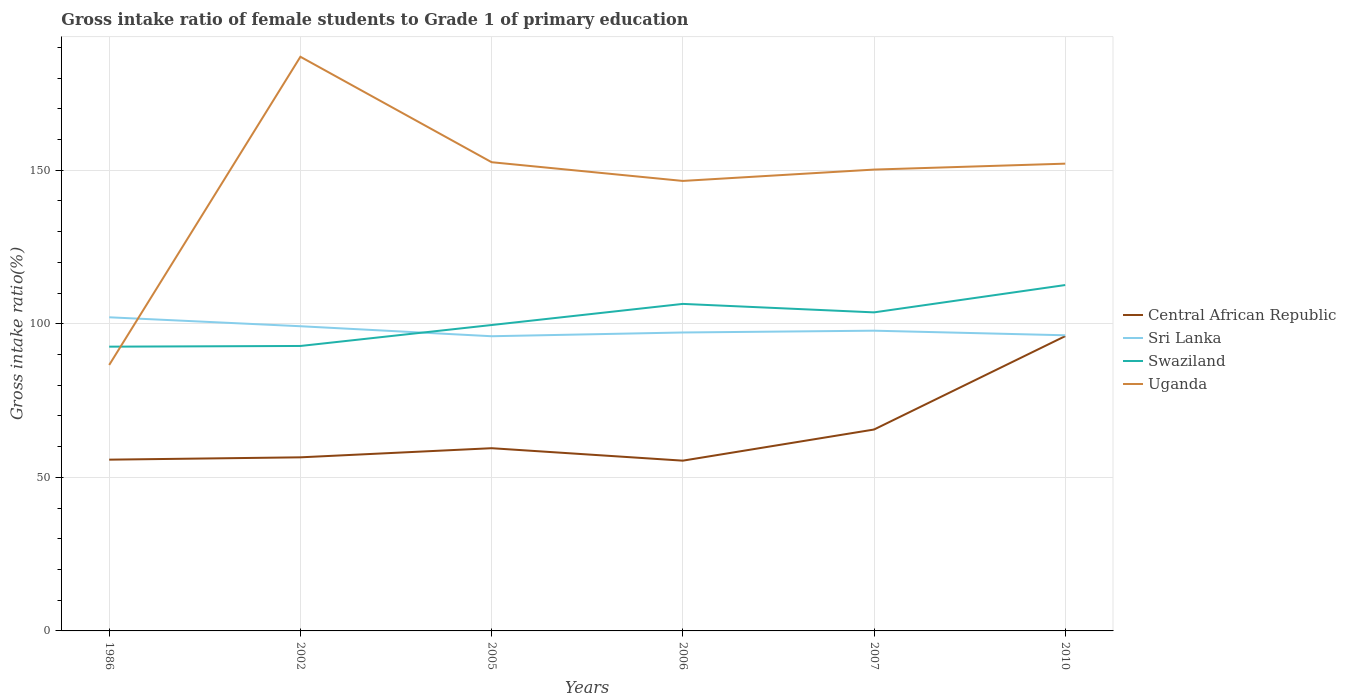Does the line corresponding to Swaziland intersect with the line corresponding to Central African Republic?
Your answer should be compact. No. Is the number of lines equal to the number of legend labels?
Keep it short and to the point. Yes. Across all years, what is the maximum gross intake ratio in Central African Republic?
Provide a succinct answer. 55.44. In which year was the gross intake ratio in Uganda maximum?
Offer a very short reply. 1986. What is the total gross intake ratio in Sri Lanka in the graph?
Offer a terse response. 1.49. What is the difference between the highest and the second highest gross intake ratio in Sri Lanka?
Offer a very short reply. 6.17. Is the gross intake ratio in Swaziland strictly greater than the gross intake ratio in Uganda over the years?
Provide a short and direct response. No. How many years are there in the graph?
Give a very brief answer. 6. Are the values on the major ticks of Y-axis written in scientific E-notation?
Make the answer very short. No. Does the graph contain grids?
Your response must be concise. Yes. What is the title of the graph?
Provide a succinct answer. Gross intake ratio of female students to Grade 1 of primary education. Does "Cameroon" appear as one of the legend labels in the graph?
Offer a terse response. No. What is the label or title of the Y-axis?
Offer a very short reply. Gross intake ratio(%). What is the Gross intake ratio(%) in Central African Republic in 1986?
Offer a terse response. 55.77. What is the Gross intake ratio(%) in Sri Lanka in 1986?
Keep it short and to the point. 102.13. What is the Gross intake ratio(%) of Swaziland in 1986?
Offer a terse response. 92.57. What is the Gross intake ratio(%) in Uganda in 1986?
Make the answer very short. 86.6. What is the Gross intake ratio(%) in Central African Republic in 2002?
Your answer should be compact. 56.53. What is the Gross intake ratio(%) of Sri Lanka in 2002?
Offer a terse response. 99.21. What is the Gross intake ratio(%) of Swaziland in 2002?
Ensure brevity in your answer.  92.79. What is the Gross intake ratio(%) in Uganda in 2002?
Your answer should be compact. 186.96. What is the Gross intake ratio(%) in Central African Republic in 2005?
Keep it short and to the point. 59.5. What is the Gross intake ratio(%) of Sri Lanka in 2005?
Keep it short and to the point. 95.96. What is the Gross intake ratio(%) in Swaziland in 2005?
Give a very brief answer. 99.61. What is the Gross intake ratio(%) of Uganda in 2005?
Make the answer very short. 152.63. What is the Gross intake ratio(%) in Central African Republic in 2006?
Your answer should be very brief. 55.44. What is the Gross intake ratio(%) in Sri Lanka in 2006?
Your answer should be very brief. 97.18. What is the Gross intake ratio(%) in Swaziland in 2006?
Ensure brevity in your answer.  106.49. What is the Gross intake ratio(%) in Uganda in 2006?
Provide a succinct answer. 146.53. What is the Gross intake ratio(%) of Central African Republic in 2007?
Your answer should be compact. 65.58. What is the Gross intake ratio(%) of Sri Lanka in 2007?
Make the answer very short. 97.76. What is the Gross intake ratio(%) of Swaziland in 2007?
Your response must be concise. 103.73. What is the Gross intake ratio(%) in Uganda in 2007?
Give a very brief answer. 150.23. What is the Gross intake ratio(%) of Central African Republic in 2010?
Your response must be concise. 95.99. What is the Gross intake ratio(%) of Sri Lanka in 2010?
Your response must be concise. 96.27. What is the Gross intake ratio(%) in Swaziland in 2010?
Ensure brevity in your answer.  112.63. What is the Gross intake ratio(%) in Uganda in 2010?
Provide a short and direct response. 152.16. Across all years, what is the maximum Gross intake ratio(%) of Central African Republic?
Offer a terse response. 95.99. Across all years, what is the maximum Gross intake ratio(%) of Sri Lanka?
Offer a terse response. 102.13. Across all years, what is the maximum Gross intake ratio(%) in Swaziland?
Offer a very short reply. 112.63. Across all years, what is the maximum Gross intake ratio(%) of Uganda?
Make the answer very short. 186.96. Across all years, what is the minimum Gross intake ratio(%) in Central African Republic?
Your answer should be very brief. 55.44. Across all years, what is the minimum Gross intake ratio(%) in Sri Lanka?
Your answer should be very brief. 95.96. Across all years, what is the minimum Gross intake ratio(%) in Swaziland?
Offer a very short reply. 92.57. Across all years, what is the minimum Gross intake ratio(%) of Uganda?
Keep it short and to the point. 86.6. What is the total Gross intake ratio(%) of Central African Republic in the graph?
Give a very brief answer. 388.81. What is the total Gross intake ratio(%) of Sri Lanka in the graph?
Your response must be concise. 588.52. What is the total Gross intake ratio(%) of Swaziland in the graph?
Keep it short and to the point. 607.82. What is the total Gross intake ratio(%) of Uganda in the graph?
Offer a very short reply. 875.12. What is the difference between the Gross intake ratio(%) in Central African Republic in 1986 and that in 2002?
Offer a terse response. -0.76. What is the difference between the Gross intake ratio(%) of Sri Lanka in 1986 and that in 2002?
Your answer should be very brief. 2.91. What is the difference between the Gross intake ratio(%) of Swaziland in 1986 and that in 2002?
Your response must be concise. -0.22. What is the difference between the Gross intake ratio(%) in Uganda in 1986 and that in 2002?
Give a very brief answer. -100.36. What is the difference between the Gross intake ratio(%) in Central African Republic in 1986 and that in 2005?
Ensure brevity in your answer.  -3.73. What is the difference between the Gross intake ratio(%) of Sri Lanka in 1986 and that in 2005?
Ensure brevity in your answer.  6.17. What is the difference between the Gross intake ratio(%) in Swaziland in 1986 and that in 2005?
Ensure brevity in your answer.  -7.05. What is the difference between the Gross intake ratio(%) of Uganda in 1986 and that in 2005?
Provide a short and direct response. -66.03. What is the difference between the Gross intake ratio(%) in Central African Republic in 1986 and that in 2006?
Your answer should be very brief. 0.33. What is the difference between the Gross intake ratio(%) in Sri Lanka in 1986 and that in 2006?
Keep it short and to the point. 4.95. What is the difference between the Gross intake ratio(%) of Swaziland in 1986 and that in 2006?
Keep it short and to the point. -13.92. What is the difference between the Gross intake ratio(%) in Uganda in 1986 and that in 2006?
Offer a very short reply. -59.93. What is the difference between the Gross intake ratio(%) in Central African Republic in 1986 and that in 2007?
Ensure brevity in your answer.  -9.81. What is the difference between the Gross intake ratio(%) of Sri Lanka in 1986 and that in 2007?
Give a very brief answer. 4.37. What is the difference between the Gross intake ratio(%) in Swaziland in 1986 and that in 2007?
Keep it short and to the point. -11.16. What is the difference between the Gross intake ratio(%) of Uganda in 1986 and that in 2007?
Your answer should be compact. -63.63. What is the difference between the Gross intake ratio(%) of Central African Republic in 1986 and that in 2010?
Keep it short and to the point. -40.23. What is the difference between the Gross intake ratio(%) in Sri Lanka in 1986 and that in 2010?
Your answer should be very brief. 5.86. What is the difference between the Gross intake ratio(%) of Swaziland in 1986 and that in 2010?
Your answer should be compact. -20.07. What is the difference between the Gross intake ratio(%) of Uganda in 1986 and that in 2010?
Your answer should be compact. -65.56. What is the difference between the Gross intake ratio(%) in Central African Republic in 2002 and that in 2005?
Make the answer very short. -2.97. What is the difference between the Gross intake ratio(%) of Sri Lanka in 2002 and that in 2005?
Provide a succinct answer. 3.25. What is the difference between the Gross intake ratio(%) in Swaziland in 2002 and that in 2005?
Offer a very short reply. -6.82. What is the difference between the Gross intake ratio(%) in Uganda in 2002 and that in 2005?
Offer a terse response. 34.33. What is the difference between the Gross intake ratio(%) of Central African Republic in 2002 and that in 2006?
Offer a very short reply. 1.08. What is the difference between the Gross intake ratio(%) of Sri Lanka in 2002 and that in 2006?
Offer a terse response. 2.03. What is the difference between the Gross intake ratio(%) of Swaziland in 2002 and that in 2006?
Keep it short and to the point. -13.7. What is the difference between the Gross intake ratio(%) of Uganda in 2002 and that in 2006?
Make the answer very short. 40.43. What is the difference between the Gross intake ratio(%) of Central African Republic in 2002 and that in 2007?
Your response must be concise. -9.05. What is the difference between the Gross intake ratio(%) in Sri Lanka in 2002 and that in 2007?
Provide a succinct answer. 1.45. What is the difference between the Gross intake ratio(%) in Swaziland in 2002 and that in 2007?
Provide a short and direct response. -10.94. What is the difference between the Gross intake ratio(%) of Uganda in 2002 and that in 2007?
Provide a short and direct response. 36.73. What is the difference between the Gross intake ratio(%) in Central African Republic in 2002 and that in 2010?
Offer a terse response. -39.47. What is the difference between the Gross intake ratio(%) in Sri Lanka in 2002 and that in 2010?
Give a very brief answer. 2.95. What is the difference between the Gross intake ratio(%) of Swaziland in 2002 and that in 2010?
Provide a short and direct response. -19.84. What is the difference between the Gross intake ratio(%) in Uganda in 2002 and that in 2010?
Offer a very short reply. 34.8. What is the difference between the Gross intake ratio(%) of Central African Republic in 2005 and that in 2006?
Offer a very short reply. 4.06. What is the difference between the Gross intake ratio(%) in Sri Lanka in 2005 and that in 2006?
Make the answer very short. -1.22. What is the difference between the Gross intake ratio(%) of Swaziland in 2005 and that in 2006?
Keep it short and to the point. -6.88. What is the difference between the Gross intake ratio(%) of Uganda in 2005 and that in 2006?
Keep it short and to the point. 6.09. What is the difference between the Gross intake ratio(%) in Central African Republic in 2005 and that in 2007?
Your answer should be very brief. -6.08. What is the difference between the Gross intake ratio(%) of Sri Lanka in 2005 and that in 2007?
Ensure brevity in your answer.  -1.8. What is the difference between the Gross intake ratio(%) of Swaziland in 2005 and that in 2007?
Give a very brief answer. -4.12. What is the difference between the Gross intake ratio(%) of Uganda in 2005 and that in 2007?
Provide a succinct answer. 2.4. What is the difference between the Gross intake ratio(%) of Central African Republic in 2005 and that in 2010?
Provide a succinct answer. -36.49. What is the difference between the Gross intake ratio(%) in Sri Lanka in 2005 and that in 2010?
Provide a succinct answer. -0.31. What is the difference between the Gross intake ratio(%) of Swaziland in 2005 and that in 2010?
Your answer should be very brief. -13.02. What is the difference between the Gross intake ratio(%) in Uganda in 2005 and that in 2010?
Ensure brevity in your answer.  0.47. What is the difference between the Gross intake ratio(%) of Central African Republic in 2006 and that in 2007?
Ensure brevity in your answer.  -10.14. What is the difference between the Gross intake ratio(%) in Sri Lanka in 2006 and that in 2007?
Give a very brief answer. -0.58. What is the difference between the Gross intake ratio(%) in Swaziland in 2006 and that in 2007?
Provide a short and direct response. 2.76. What is the difference between the Gross intake ratio(%) of Uganda in 2006 and that in 2007?
Provide a succinct answer. -3.69. What is the difference between the Gross intake ratio(%) of Central African Republic in 2006 and that in 2010?
Provide a short and direct response. -40.55. What is the difference between the Gross intake ratio(%) in Sri Lanka in 2006 and that in 2010?
Ensure brevity in your answer.  0.91. What is the difference between the Gross intake ratio(%) in Swaziland in 2006 and that in 2010?
Ensure brevity in your answer.  -6.14. What is the difference between the Gross intake ratio(%) in Uganda in 2006 and that in 2010?
Your response must be concise. -5.63. What is the difference between the Gross intake ratio(%) of Central African Republic in 2007 and that in 2010?
Give a very brief answer. -30.41. What is the difference between the Gross intake ratio(%) in Sri Lanka in 2007 and that in 2010?
Your answer should be compact. 1.49. What is the difference between the Gross intake ratio(%) of Swaziland in 2007 and that in 2010?
Your answer should be compact. -8.9. What is the difference between the Gross intake ratio(%) in Uganda in 2007 and that in 2010?
Make the answer very short. -1.93. What is the difference between the Gross intake ratio(%) in Central African Republic in 1986 and the Gross intake ratio(%) in Sri Lanka in 2002?
Give a very brief answer. -43.45. What is the difference between the Gross intake ratio(%) of Central African Republic in 1986 and the Gross intake ratio(%) of Swaziland in 2002?
Provide a succinct answer. -37.02. What is the difference between the Gross intake ratio(%) of Central African Republic in 1986 and the Gross intake ratio(%) of Uganda in 2002?
Make the answer very short. -131.19. What is the difference between the Gross intake ratio(%) of Sri Lanka in 1986 and the Gross intake ratio(%) of Swaziland in 2002?
Provide a short and direct response. 9.34. What is the difference between the Gross intake ratio(%) in Sri Lanka in 1986 and the Gross intake ratio(%) in Uganda in 2002?
Your answer should be compact. -84.83. What is the difference between the Gross intake ratio(%) in Swaziland in 1986 and the Gross intake ratio(%) in Uganda in 2002?
Give a very brief answer. -94.4. What is the difference between the Gross intake ratio(%) of Central African Republic in 1986 and the Gross intake ratio(%) of Sri Lanka in 2005?
Ensure brevity in your answer.  -40.19. What is the difference between the Gross intake ratio(%) in Central African Republic in 1986 and the Gross intake ratio(%) in Swaziland in 2005?
Keep it short and to the point. -43.84. What is the difference between the Gross intake ratio(%) in Central African Republic in 1986 and the Gross intake ratio(%) in Uganda in 2005?
Offer a very short reply. -96.86. What is the difference between the Gross intake ratio(%) of Sri Lanka in 1986 and the Gross intake ratio(%) of Swaziland in 2005?
Your answer should be very brief. 2.52. What is the difference between the Gross intake ratio(%) in Sri Lanka in 1986 and the Gross intake ratio(%) in Uganda in 2005?
Ensure brevity in your answer.  -50.5. What is the difference between the Gross intake ratio(%) in Swaziland in 1986 and the Gross intake ratio(%) in Uganda in 2005?
Your response must be concise. -60.06. What is the difference between the Gross intake ratio(%) of Central African Republic in 1986 and the Gross intake ratio(%) of Sri Lanka in 2006?
Make the answer very short. -41.41. What is the difference between the Gross intake ratio(%) in Central African Republic in 1986 and the Gross intake ratio(%) in Swaziland in 2006?
Your answer should be very brief. -50.72. What is the difference between the Gross intake ratio(%) in Central African Republic in 1986 and the Gross intake ratio(%) in Uganda in 2006?
Provide a succinct answer. -90.76. What is the difference between the Gross intake ratio(%) in Sri Lanka in 1986 and the Gross intake ratio(%) in Swaziland in 2006?
Give a very brief answer. -4.36. What is the difference between the Gross intake ratio(%) in Sri Lanka in 1986 and the Gross intake ratio(%) in Uganda in 2006?
Provide a short and direct response. -44.4. What is the difference between the Gross intake ratio(%) in Swaziland in 1986 and the Gross intake ratio(%) in Uganda in 2006?
Your answer should be very brief. -53.97. What is the difference between the Gross intake ratio(%) of Central African Republic in 1986 and the Gross intake ratio(%) of Sri Lanka in 2007?
Provide a short and direct response. -42. What is the difference between the Gross intake ratio(%) of Central African Republic in 1986 and the Gross intake ratio(%) of Swaziland in 2007?
Keep it short and to the point. -47.96. What is the difference between the Gross intake ratio(%) in Central African Republic in 1986 and the Gross intake ratio(%) in Uganda in 2007?
Provide a short and direct response. -94.46. What is the difference between the Gross intake ratio(%) in Sri Lanka in 1986 and the Gross intake ratio(%) in Swaziland in 2007?
Give a very brief answer. -1.6. What is the difference between the Gross intake ratio(%) in Sri Lanka in 1986 and the Gross intake ratio(%) in Uganda in 2007?
Give a very brief answer. -48.1. What is the difference between the Gross intake ratio(%) in Swaziland in 1986 and the Gross intake ratio(%) in Uganda in 2007?
Your answer should be very brief. -57.66. What is the difference between the Gross intake ratio(%) of Central African Republic in 1986 and the Gross intake ratio(%) of Sri Lanka in 2010?
Keep it short and to the point. -40.5. What is the difference between the Gross intake ratio(%) of Central African Republic in 1986 and the Gross intake ratio(%) of Swaziland in 2010?
Your answer should be very brief. -56.86. What is the difference between the Gross intake ratio(%) in Central African Republic in 1986 and the Gross intake ratio(%) in Uganda in 2010?
Your answer should be very brief. -96.39. What is the difference between the Gross intake ratio(%) of Sri Lanka in 1986 and the Gross intake ratio(%) of Swaziland in 2010?
Your answer should be compact. -10.5. What is the difference between the Gross intake ratio(%) in Sri Lanka in 1986 and the Gross intake ratio(%) in Uganda in 2010?
Give a very brief answer. -50.03. What is the difference between the Gross intake ratio(%) of Swaziland in 1986 and the Gross intake ratio(%) of Uganda in 2010?
Your answer should be compact. -59.59. What is the difference between the Gross intake ratio(%) in Central African Republic in 2002 and the Gross intake ratio(%) in Sri Lanka in 2005?
Provide a succinct answer. -39.43. What is the difference between the Gross intake ratio(%) of Central African Republic in 2002 and the Gross intake ratio(%) of Swaziland in 2005?
Provide a succinct answer. -43.09. What is the difference between the Gross intake ratio(%) of Central African Republic in 2002 and the Gross intake ratio(%) of Uganda in 2005?
Provide a succinct answer. -96.1. What is the difference between the Gross intake ratio(%) of Sri Lanka in 2002 and the Gross intake ratio(%) of Swaziland in 2005?
Provide a succinct answer. -0.4. What is the difference between the Gross intake ratio(%) in Sri Lanka in 2002 and the Gross intake ratio(%) in Uganda in 2005?
Make the answer very short. -53.41. What is the difference between the Gross intake ratio(%) in Swaziland in 2002 and the Gross intake ratio(%) in Uganda in 2005?
Your response must be concise. -59.84. What is the difference between the Gross intake ratio(%) in Central African Republic in 2002 and the Gross intake ratio(%) in Sri Lanka in 2006?
Your response must be concise. -40.66. What is the difference between the Gross intake ratio(%) of Central African Republic in 2002 and the Gross intake ratio(%) of Swaziland in 2006?
Your answer should be compact. -49.96. What is the difference between the Gross intake ratio(%) in Central African Republic in 2002 and the Gross intake ratio(%) in Uganda in 2006?
Your answer should be very brief. -90.01. What is the difference between the Gross intake ratio(%) of Sri Lanka in 2002 and the Gross intake ratio(%) of Swaziland in 2006?
Offer a terse response. -7.27. What is the difference between the Gross intake ratio(%) of Sri Lanka in 2002 and the Gross intake ratio(%) of Uganda in 2006?
Offer a very short reply. -47.32. What is the difference between the Gross intake ratio(%) of Swaziland in 2002 and the Gross intake ratio(%) of Uganda in 2006?
Make the answer very short. -53.75. What is the difference between the Gross intake ratio(%) in Central African Republic in 2002 and the Gross intake ratio(%) in Sri Lanka in 2007?
Your answer should be very brief. -41.24. What is the difference between the Gross intake ratio(%) of Central African Republic in 2002 and the Gross intake ratio(%) of Swaziland in 2007?
Keep it short and to the point. -47.2. What is the difference between the Gross intake ratio(%) of Central African Republic in 2002 and the Gross intake ratio(%) of Uganda in 2007?
Offer a terse response. -93.7. What is the difference between the Gross intake ratio(%) in Sri Lanka in 2002 and the Gross intake ratio(%) in Swaziland in 2007?
Offer a terse response. -4.51. What is the difference between the Gross intake ratio(%) of Sri Lanka in 2002 and the Gross intake ratio(%) of Uganda in 2007?
Provide a succinct answer. -51.01. What is the difference between the Gross intake ratio(%) in Swaziland in 2002 and the Gross intake ratio(%) in Uganda in 2007?
Your answer should be very brief. -57.44. What is the difference between the Gross intake ratio(%) of Central African Republic in 2002 and the Gross intake ratio(%) of Sri Lanka in 2010?
Offer a terse response. -39.74. What is the difference between the Gross intake ratio(%) of Central African Republic in 2002 and the Gross intake ratio(%) of Swaziland in 2010?
Your answer should be very brief. -56.11. What is the difference between the Gross intake ratio(%) in Central African Republic in 2002 and the Gross intake ratio(%) in Uganda in 2010?
Provide a succinct answer. -95.63. What is the difference between the Gross intake ratio(%) of Sri Lanka in 2002 and the Gross intake ratio(%) of Swaziland in 2010?
Ensure brevity in your answer.  -13.42. What is the difference between the Gross intake ratio(%) of Sri Lanka in 2002 and the Gross intake ratio(%) of Uganda in 2010?
Your answer should be compact. -52.94. What is the difference between the Gross intake ratio(%) of Swaziland in 2002 and the Gross intake ratio(%) of Uganda in 2010?
Make the answer very short. -59.37. What is the difference between the Gross intake ratio(%) in Central African Republic in 2005 and the Gross intake ratio(%) in Sri Lanka in 2006?
Offer a very short reply. -37.68. What is the difference between the Gross intake ratio(%) of Central African Republic in 2005 and the Gross intake ratio(%) of Swaziland in 2006?
Offer a very short reply. -46.99. What is the difference between the Gross intake ratio(%) in Central African Republic in 2005 and the Gross intake ratio(%) in Uganda in 2006?
Offer a very short reply. -87.03. What is the difference between the Gross intake ratio(%) of Sri Lanka in 2005 and the Gross intake ratio(%) of Swaziland in 2006?
Provide a short and direct response. -10.53. What is the difference between the Gross intake ratio(%) in Sri Lanka in 2005 and the Gross intake ratio(%) in Uganda in 2006?
Keep it short and to the point. -50.57. What is the difference between the Gross intake ratio(%) in Swaziland in 2005 and the Gross intake ratio(%) in Uganda in 2006?
Offer a terse response. -46.92. What is the difference between the Gross intake ratio(%) of Central African Republic in 2005 and the Gross intake ratio(%) of Sri Lanka in 2007?
Provide a succinct answer. -38.26. What is the difference between the Gross intake ratio(%) of Central African Republic in 2005 and the Gross intake ratio(%) of Swaziland in 2007?
Make the answer very short. -44.23. What is the difference between the Gross intake ratio(%) in Central African Republic in 2005 and the Gross intake ratio(%) in Uganda in 2007?
Offer a very short reply. -90.73. What is the difference between the Gross intake ratio(%) of Sri Lanka in 2005 and the Gross intake ratio(%) of Swaziland in 2007?
Make the answer very short. -7.77. What is the difference between the Gross intake ratio(%) in Sri Lanka in 2005 and the Gross intake ratio(%) in Uganda in 2007?
Provide a succinct answer. -54.27. What is the difference between the Gross intake ratio(%) in Swaziland in 2005 and the Gross intake ratio(%) in Uganda in 2007?
Offer a terse response. -50.62. What is the difference between the Gross intake ratio(%) of Central African Republic in 2005 and the Gross intake ratio(%) of Sri Lanka in 2010?
Give a very brief answer. -36.77. What is the difference between the Gross intake ratio(%) of Central African Republic in 2005 and the Gross intake ratio(%) of Swaziland in 2010?
Ensure brevity in your answer.  -53.13. What is the difference between the Gross intake ratio(%) in Central African Republic in 2005 and the Gross intake ratio(%) in Uganda in 2010?
Offer a terse response. -92.66. What is the difference between the Gross intake ratio(%) in Sri Lanka in 2005 and the Gross intake ratio(%) in Swaziland in 2010?
Offer a terse response. -16.67. What is the difference between the Gross intake ratio(%) of Sri Lanka in 2005 and the Gross intake ratio(%) of Uganda in 2010?
Provide a succinct answer. -56.2. What is the difference between the Gross intake ratio(%) in Swaziland in 2005 and the Gross intake ratio(%) in Uganda in 2010?
Keep it short and to the point. -52.55. What is the difference between the Gross intake ratio(%) of Central African Republic in 2006 and the Gross intake ratio(%) of Sri Lanka in 2007?
Provide a short and direct response. -42.32. What is the difference between the Gross intake ratio(%) in Central African Republic in 2006 and the Gross intake ratio(%) in Swaziland in 2007?
Offer a terse response. -48.29. What is the difference between the Gross intake ratio(%) in Central African Republic in 2006 and the Gross intake ratio(%) in Uganda in 2007?
Provide a short and direct response. -94.79. What is the difference between the Gross intake ratio(%) of Sri Lanka in 2006 and the Gross intake ratio(%) of Swaziland in 2007?
Your response must be concise. -6.55. What is the difference between the Gross intake ratio(%) in Sri Lanka in 2006 and the Gross intake ratio(%) in Uganda in 2007?
Make the answer very short. -53.05. What is the difference between the Gross intake ratio(%) in Swaziland in 2006 and the Gross intake ratio(%) in Uganda in 2007?
Your response must be concise. -43.74. What is the difference between the Gross intake ratio(%) of Central African Republic in 2006 and the Gross intake ratio(%) of Sri Lanka in 2010?
Offer a terse response. -40.83. What is the difference between the Gross intake ratio(%) of Central African Republic in 2006 and the Gross intake ratio(%) of Swaziland in 2010?
Offer a very short reply. -57.19. What is the difference between the Gross intake ratio(%) of Central African Republic in 2006 and the Gross intake ratio(%) of Uganda in 2010?
Your answer should be compact. -96.72. What is the difference between the Gross intake ratio(%) in Sri Lanka in 2006 and the Gross intake ratio(%) in Swaziland in 2010?
Provide a succinct answer. -15.45. What is the difference between the Gross intake ratio(%) in Sri Lanka in 2006 and the Gross intake ratio(%) in Uganda in 2010?
Your answer should be compact. -54.98. What is the difference between the Gross intake ratio(%) of Swaziland in 2006 and the Gross intake ratio(%) of Uganda in 2010?
Offer a very short reply. -45.67. What is the difference between the Gross intake ratio(%) of Central African Republic in 2007 and the Gross intake ratio(%) of Sri Lanka in 2010?
Provide a short and direct response. -30.69. What is the difference between the Gross intake ratio(%) in Central African Republic in 2007 and the Gross intake ratio(%) in Swaziland in 2010?
Ensure brevity in your answer.  -47.05. What is the difference between the Gross intake ratio(%) of Central African Republic in 2007 and the Gross intake ratio(%) of Uganda in 2010?
Make the answer very short. -86.58. What is the difference between the Gross intake ratio(%) in Sri Lanka in 2007 and the Gross intake ratio(%) in Swaziland in 2010?
Your response must be concise. -14.87. What is the difference between the Gross intake ratio(%) in Sri Lanka in 2007 and the Gross intake ratio(%) in Uganda in 2010?
Keep it short and to the point. -54.39. What is the difference between the Gross intake ratio(%) of Swaziland in 2007 and the Gross intake ratio(%) of Uganda in 2010?
Provide a succinct answer. -48.43. What is the average Gross intake ratio(%) in Central African Republic per year?
Ensure brevity in your answer.  64.8. What is the average Gross intake ratio(%) in Sri Lanka per year?
Your answer should be very brief. 98.09. What is the average Gross intake ratio(%) in Swaziland per year?
Offer a very short reply. 101.3. What is the average Gross intake ratio(%) in Uganda per year?
Ensure brevity in your answer.  145.85. In the year 1986, what is the difference between the Gross intake ratio(%) of Central African Republic and Gross intake ratio(%) of Sri Lanka?
Provide a short and direct response. -46.36. In the year 1986, what is the difference between the Gross intake ratio(%) of Central African Republic and Gross intake ratio(%) of Swaziland?
Offer a terse response. -36.8. In the year 1986, what is the difference between the Gross intake ratio(%) of Central African Republic and Gross intake ratio(%) of Uganda?
Ensure brevity in your answer.  -30.83. In the year 1986, what is the difference between the Gross intake ratio(%) of Sri Lanka and Gross intake ratio(%) of Swaziland?
Make the answer very short. 9.56. In the year 1986, what is the difference between the Gross intake ratio(%) of Sri Lanka and Gross intake ratio(%) of Uganda?
Your answer should be very brief. 15.53. In the year 1986, what is the difference between the Gross intake ratio(%) of Swaziland and Gross intake ratio(%) of Uganda?
Offer a terse response. 5.96. In the year 2002, what is the difference between the Gross intake ratio(%) of Central African Republic and Gross intake ratio(%) of Sri Lanka?
Your answer should be compact. -42.69. In the year 2002, what is the difference between the Gross intake ratio(%) of Central African Republic and Gross intake ratio(%) of Swaziland?
Your answer should be compact. -36.26. In the year 2002, what is the difference between the Gross intake ratio(%) of Central African Republic and Gross intake ratio(%) of Uganda?
Offer a terse response. -130.44. In the year 2002, what is the difference between the Gross intake ratio(%) in Sri Lanka and Gross intake ratio(%) in Swaziland?
Ensure brevity in your answer.  6.43. In the year 2002, what is the difference between the Gross intake ratio(%) in Sri Lanka and Gross intake ratio(%) in Uganda?
Offer a terse response. -87.75. In the year 2002, what is the difference between the Gross intake ratio(%) of Swaziland and Gross intake ratio(%) of Uganda?
Give a very brief answer. -94.18. In the year 2005, what is the difference between the Gross intake ratio(%) of Central African Republic and Gross intake ratio(%) of Sri Lanka?
Make the answer very short. -36.46. In the year 2005, what is the difference between the Gross intake ratio(%) of Central African Republic and Gross intake ratio(%) of Swaziland?
Offer a very short reply. -40.11. In the year 2005, what is the difference between the Gross intake ratio(%) of Central African Republic and Gross intake ratio(%) of Uganda?
Your response must be concise. -93.13. In the year 2005, what is the difference between the Gross intake ratio(%) in Sri Lanka and Gross intake ratio(%) in Swaziland?
Your answer should be compact. -3.65. In the year 2005, what is the difference between the Gross intake ratio(%) in Sri Lanka and Gross intake ratio(%) in Uganda?
Keep it short and to the point. -56.67. In the year 2005, what is the difference between the Gross intake ratio(%) in Swaziland and Gross intake ratio(%) in Uganda?
Offer a terse response. -53.02. In the year 2006, what is the difference between the Gross intake ratio(%) of Central African Republic and Gross intake ratio(%) of Sri Lanka?
Offer a very short reply. -41.74. In the year 2006, what is the difference between the Gross intake ratio(%) in Central African Republic and Gross intake ratio(%) in Swaziland?
Ensure brevity in your answer.  -51.05. In the year 2006, what is the difference between the Gross intake ratio(%) in Central African Republic and Gross intake ratio(%) in Uganda?
Make the answer very short. -91.09. In the year 2006, what is the difference between the Gross intake ratio(%) in Sri Lanka and Gross intake ratio(%) in Swaziland?
Your response must be concise. -9.31. In the year 2006, what is the difference between the Gross intake ratio(%) of Sri Lanka and Gross intake ratio(%) of Uganda?
Your answer should be very brief. -49.35. In the year 2006, what is the difference between the Gross intake ratio(%) of Swaziland and Gross intake ratio(%) of Uganda?
Keep it short and to the point. -40.04. In the year 2007, what is the difference between the Gross intake ratio(%) in Central African Republic and Gross intake ratio(%) in Sri Lanka?
Provide a succinct answer. -32.18. In the year 2007, what is the difference between the Gross intake ratio(%) of Central African Republic and Gross intake ratio(%) of Swaziland?
Provide a succinct answer. -38.15. In the year 2007, what is the difference between the Gross intake ratio(%) of Central African Republic and Gross intake ratio(%) of Uganda?
Provide a succinct answer. -84.65. In the year 2007, what is the difference between the Gross intake ratio(%) in Sri Lanka and Gross intake ratio(%) in Swaziland?
Provide a short and direct response. -5.96. In the year 2007, what is the difference between the Gross intake ratio(%) in Sri Lanka and Gross intake ratio(%) in Uganda?
Keep it short and to the point. -52.46. In the year 2007, what is the difference between the Gross intake ratio(%) in Swaziland and Gross intake ratio(%) in Uganda?
Give a very brief answer. -46.5. In the year 2010, what is the difference between the Gross intake ratio(%) of Central African Republic and Gross intake ratio(%) of Sri Lanka?
Offer a terse response. -0.28. In the year 2010, what is the difference between the Gross intake ratio(%) of Central African Republic and Gross intake ratio(%) of Swaziland?
Offer a very short reply. -16.64. In the year 2010, what is the difference between the Gross intake ratio(%) in Central African Republic and Gross intake ratio(%) in Uganda?
Your answer should be compact. -56.16. In the year 2010, what is the difference between the Gross intake ratio(%) of Sri Lanka and Gross intake ratio(%) of Swaziland?
Your answer should be compact. -16.36. In the year 2010, what is the difference between the Gross intake ratio(%) in Sri Lanka and Gross intake ratio(%) in Uganda?
Provide a succinct answer. -55.89. In the year 2010, what is the difference between the Gross intake ratio(%) in Swaziland and Gross intake ratio(%) in Uganda?
Provide a short and direct response. -39.53. What is the ratio of the Gross intake ratio(%) in Central African Republic in 1986 to that in 2002?
Keep it short and to the point. 0.99. What is the ratio of the Gross intake ratio(%) in Sri Lanka in 1986 to that in 2002?
Your answer should be very brief. 1.03. What is the ratio of the Gross intake ratio(%) in Swaziland in 1986 to that in 2002?
Offer a very short reply. 1. What is the ratio of the Gross intake ratio(%) in Uganda in 1986 to that in 2002?
Keep it short and to the point. 0.46. What is the ratio of the Gross intake ratio(%) in Central African Republic in 1986 to that in 2005?
Your answer should be very brief. 0.94. What is the ratio of the Gross intake ratio(%) of Sri Lanka in 1986 to that in 2005?
Offer a terse response. 1.06. What is the ratio of the Gross intake ratio(%) in Swaziland in 1986 to that in 2005?
Your answer should be compact. 0.93. What is the ratio of the Gross intake ratio(%) of Uganda in 1986 to that in 2005?
Make the answer very short. 0.57. What is the ratio of the Gross intake ratio(%) of Central African Republic in 1986 to that in 2006?
Ensure brevity in your answer.  1.01. What is the ratio of the Gross intake ratio(%) of Sri Lanka in 1986 to that in 2006?
Ensure brevity in your answer.  1.05. What is the ratio of the Gross intake ratio(%) of Swaziland in 1986 to that in 2006?
Provide a succinct answer. 0.87. What is the ratio of the Gross intake ratio(%) of Uganda in 1986 to that in 2006?
Provide a succinct answer. 0.59. What is the ratio of the Gross intake ratio(%) of Central African Republic in 1986 to that in 2007?
Your answer should be compact. 0.85. What is the ratio of the Gross intake ratio(%) of Sri Lanka in 1986 to that in 2007?
Make the answer very short. 1.04. What is the ratio of the Gross intake ratio(%) in Swaziland in 1986 to that in 2007?
Your response must be concise. 0.89. What is the ratio of the Gross intake ratio(%) of Uganda in 1986 to that in 2007?
Provide a succinct answer. 0.58. What is the ratio of the Gross intake ratio(%) in Central African Republic in 1986 to that in 2010?
Your answer should be compact. 0.58. What is the ratio of the Gross intake ratio(%) of Sri Lanka in 1986 to that in 2010?
Your answer should be very brief. 1.06. What is the ratio of the Gross intake ratio(%) of Swaziland in 1986 to that in 2010?
Provide a short and direct response. 0.82. What is the ratio of the Gross intake ratio(%) in Uganda in 1986 to that in 2010?
Your answer should be very brief. 0.57. What is the ratio of the Gross intake ratio(%) of Sri Lanka in 2002 to that in 2005?
Keep it short and to the point. 1.03. What is the ratio of the Gross intake ratio(%) of Swaziland in 2002 to that in 2005?
Provide a short and direct response. 0.93. What is the ratio of the Gross intake ratio(%) in Uganda in 2002 to that in 2005?
Give a very brief answer. 1.23. What is the ratio of the Gross intake ratio(%) of Central African Republic in 2002 to that in 2006?
Ensure brevity in your answer.  1.02. What is the ratio of the Gross intake ratio(%) in Sri Lanka in 2002 to that in 2006?
Your response must be concise. 1.02. What is the ratio of the Gross intake ratio(%) in Swaziland in 2002 to that in 2006?
Keep it short and to the point. 0.87. What is the ratio of the Gross intake ratio(%) in Uganda in 2002 to that in 2006?
Keep it short and to the point. 1.28. What is the ratio of the Gross intake ratio(%) in Central African Republic in 2002 to that in 2007?
Make the answer very short. 0.86. What is the ratio of the Gross intake ratio(%) in Sri Lanka in 2002 to that in 2007?
Make the answer very short. 1.01. What is the ratio of the Gross intake ratio(%) in Swaziland in 2002 to that in 2007?
Offer a terse response. 0.89. What is the ratio of the Gross intake ratio(%) of Uganda in 2002 to that in 2007?
Give a very brief answer. 1.24. What is the ratio of the Gross intake ratio(%) in Central African Republic in 2002 to that in 2010?
Offer a very short reply. 0.59. What is the ratio of the Gross intake ratio(%) of Sri Lanka in 2002 to that in 2010?
Provide a short and direct response. 1.03. What is the ratio of the Gross intake ratio(%) of Swaziland in 2002 to that in 2010?
Your response must be concise. 0.82. What is the ratio of the Gross intake ratio(%) of Uganda in 2002 to that in 2010?
Give a very brief answer. 1.23. What is the ratio of the Gross intake ratio(%) of Central African Republic in 2005 to that in 2006?
Offer a very short reply. 1.07. What is the ratio of the Gross intake ratio(%) of Sri Lanka in 2005 to that in 2006?
Your response must be concise. 0.99. What is the ratio of the Gross intake ratio(%) in Swaziland in 2005 to that in 2006?
Provide a succinct answer. 0.94. What is the ratio of the Gross intake ratio(%) of Uganda in 2005 to that in 2006?
Give a very brief answer. 1.04. What is the ratio of the Gross intake ratio(%) in Central African Republic in 2005 to that in 2007?
Your answer should be very brief. 0.91. What is the ratio of the Gross intake ratio(%) in Sri Lanka in 2005 to that in 2007?
Your answer should be very brief. 0.98. What is the ratio of the Gross intake ratio(%) of Swaziland in 2005 to that in 2007?
Ensure brevity in your answer.  0.96. What is the ratio of the Gross intake ratio(%) in Central African Republic in 2005 to that in 2010?
Make the answer very short. 0.62. What is the ratio of the Gross intake ratio(%) of Swaziland in 2005 to that in 2010?
Give a very brief answer. 0.88. What is the ratio of the Gross intake ratio(%) of Uganda in 2005 to that in 2010?
Provide a short and direct response. 1. What is the ratio of the Gross intake ratio(%) in Central African Republic in 2006 to that in 2007?
Ensure brevity in your answer.  0.85. What is the ratio of the Gross intake ratio(%) of Sri Lanka in 2006 to that in 2007?
Provide a succinct answer. 0.99. What is the ratio of the Gross intake ratio(%) of Swaziland in 2006 to that in 2007?
Make the answer very short. 1.03. What is the ratio of the Gross intake ratio(%) of Uganda in 2006 to that in 2007?
Keep it short and to the point. 0.98. What is the ratio of the Gross intake ratio(%) of Central African Republic in 2006 to that in 2010?
Provide a succinct answer. 0.58. What is the ratio of the Gross intake ratio(%) of Sri Lanka in 2006 to that in 2010?
Offer a terse response. 1.01. What is the ratio of the Gross intake ratio(%) of Swaziland in 2006 to that in 2010?
Offer a terse response. 0.95. What is the ratio of the Gross intake ratio(%) in Central African Republic in 2007 to that in 2010?
Your answer should be very brief. 0.68. What is the ratio of the Gross intake ratio(%) in Sri Lanka in 2007 to that in 2010?
Your response must be concise. 1.02. What is the ratio of the Gross intake ratio(%) in Swaziland in 2007 to that in 2010?
Make the answer very short. 0.92. What is the ratio of the Gross intake ratio(%) of Uganda in 2007 to that in 2010?
Offer a terse response. 0.99. What is the difference between the highest and the second highest Gross intake ratio(%) in Central African Republic?
Give a very brief answer. 30.41. What is the difference between the highest and the second highest Gross intake ratio(%) of Sri Lanka?
Your response must be concise. 2.91. What is the difference between the highest and the second highest Gross intake ratio(%) of Swaziland?
Your answer should be compact. 6.14. What is the difference between the highest and the second highest Gross intake ratio(%) of Uganda?
Keep it short and to the point. 34.33. What is the difference between the highest and the lowest Gross intake ratio(%) of Central African Republic?
Your answer should be compact. 40.55. What is the difference between the highest and the lowest Gross intake ratio(%) in Sri Lanka?
Offer a terse response. 6.17. What is the difference between the highest and the lowest Gross intake ratio(%) of Swaziland?
Your answer should be very brief. 20.07. What is the difference between the highest and the lowest Gross intake ratio(%) in Uganda?
Your answer should be compact. 100.36. 